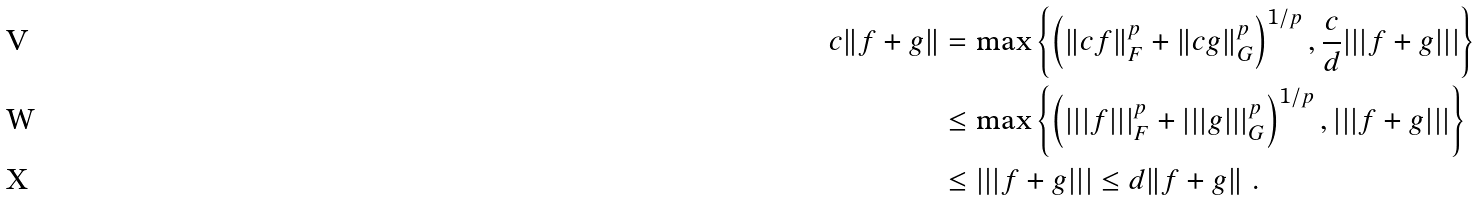<formula> <loc_0><loc_0><loc_500><loc_500>c \| f + g \| & = \max \left \{ \left ( \| c f \| _ { F } ^ { p } + \| c g \| _ { G } ^ { p } \right ) ^ { 1 / p } , \frac { c } { d } | | | f + g | | | \right \} \\ & \leq \max \left \{ \left ( | | | f | | | _ { F } ^ { p } + | | | g | | | _ { G } ^ { p } \right ) ^ { 1 / p } , | | | f + g | | | \right \} \\ & \leq | | | f + g | | | \leq d \| f + g \| \ .</formula> 